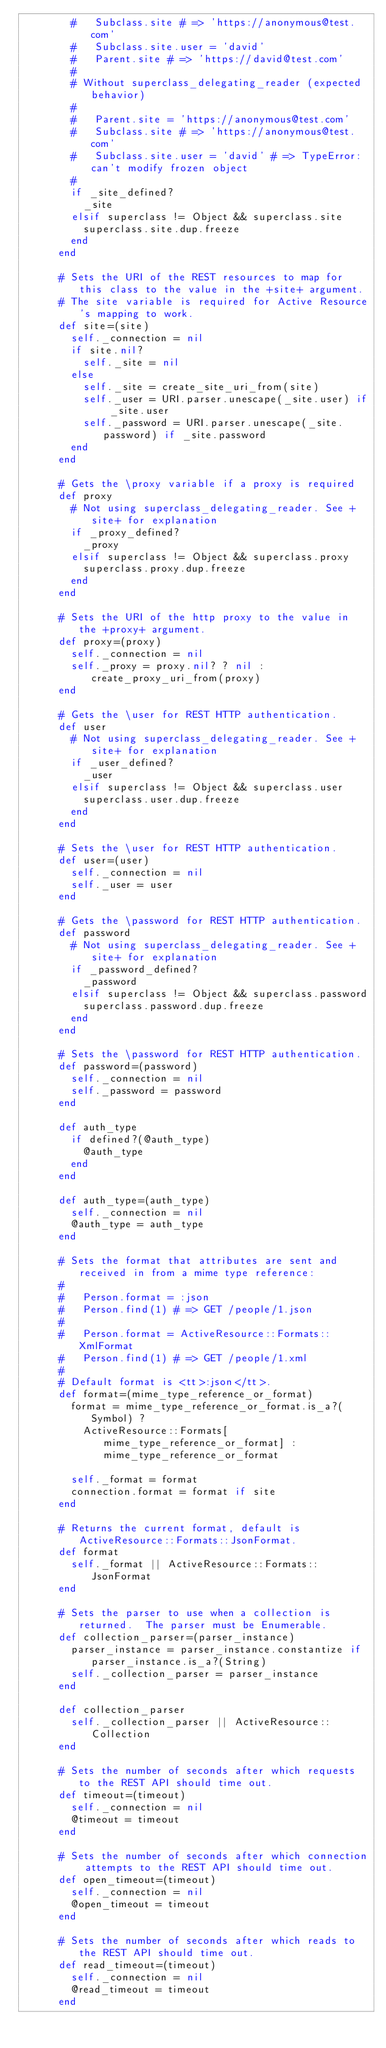Convert code to text. <code><loc_0><loc_0><loc_500><loc_500><_Ruby_>        #   Subclass.site # => 'https://anonymous@test.com'
        #   Subclass.site.user = 'david'
        #   Parent.site # => 'https://david@test.com'
        #
        # Without superclass_delegating_reader (expected behavior)
        #
        #   Parent.site = 'https://anonymous@test.com'
        #   Subclass.site # => 'https://anonymous@test.com'
        #   Subclass.site.user = 'david' # => TypeError: can't modify frozen object
        #
        if _site_defined?
          _site
        elsif superclass != Object && superclass.site
          superclass.site.dup.freeze
        end
      end

      # Sets the URI of the REST resources to map for this class to the value in the +site+ argument.
      # The site variable is required for Active Resource's mapping to work.
      def site=(site)
        self._connection = nil
        if site.nil?
          self._site = nil
        else
          self._site = create_site_uri_from(site)
          self._user = URI.parser.unescape(_site.user) if _site.user
          self._password = URI.parser.unescape(_site.password) if _site.password
        end
      end

      # Gets the \proxy variable if a proxy is required
      def proxy
        # Not using superclass_delegating_reader. See +site+ for explanation
        if _proxy_defined?
          _proxy
        elsif superclass != Object && superclass.proxy
          superclass.proxy.dup.freeze
        end
      end

      # Sets the URI of the http proxy to the value in the +proxy+ argument.
      def proxy=(proxy)
        self._connection = nil
        self._proxy = proxy.nil? ? nil : create_proxy_uri_from(proxy)
      end

      # Gets the \user for REST HTTP authentication.
      def user
        # Not using superclass_delegating_reader. See +site+ for explanation
        if _user_defined?
          _user
        elsif superclass != Object && superclass.user
          superclass.user.dup.freeze
        end
      end

      # Sets the \user for REST HTTP authentication.
      def user=(user)
        self._connection = nil
        self._user = user
      end

      # Gets the \password for REST HTTP authentication.
      def password
        # Not using superclass_delegating_reader. See +site+ for explanation
        if _password_defined?
          _password
        elsif superclass != Object && superclass.password
          superclass.password.dup.freeze
        end
      end

      # Sets the \password for REST HTTP authentication.
      def password=(password)
        self._connection = nil
        self._password = password
      end

      def auth_type
        if defined?(@auth_type)
          @auth_type
        end
      end

      def auth_type=(auth_type)
        self._connection = nil
        @auth_type = auth_type
      end

      # Sets the format that attributes are sent and received in from a mime type reference:
      #
      #   Person.format = :json
      #   Person.find(1) # => GET /people/1.json
      #
      #   Person.format = ActiveResource::Formats::XmlFormat
      #   Person.find(1) # => GET /people/1.xml
      #
      # Default format is <tt>:json</tt>.
      def format=(mime_type_reference_or_format)
        format = mime_type_reference_or_format.is_a?(Symbol) ?
          ActiveResource::Formats[mime_type_reference_or_format] : mime_type_reference_or_format

        self._format = format
        connection.format = format if site
      end

      # Returns the current format, default is ActiveResource::Formats::JsonFormat.
      def format
        self._format || ActiveResource::Formats::JsonFormat
      end

      # Sets the parser to use when a collection is returned.  The parser must be Enumerable.
      def collection_parser=(parser_instance)
        parser_instance = parser_instance.constantize if parser_instance.is_a?(String)
        self._collection_parser = parser_instance
      end

      def collection_parser
        self._collection_parser || ActiveResource::Collection
      end

      # Sets the number of seconds after which requests to the REST API should time out.
      def timeout=(timeout)
        self._connection = nil
        @timeout = timeout
      end

      # Sets the number of seconds after which connection attempts to the REST API should time out.
      def open_timeout=(timeout)
        self._connection = nil
        @open_timeout = timeout
      end

      # Sets the number of seconds after which reads to the REST API should time out.
      def read_timeout=(timeout)
        self._connection = nil
        @read_timeout = timeout
      end
</code> 